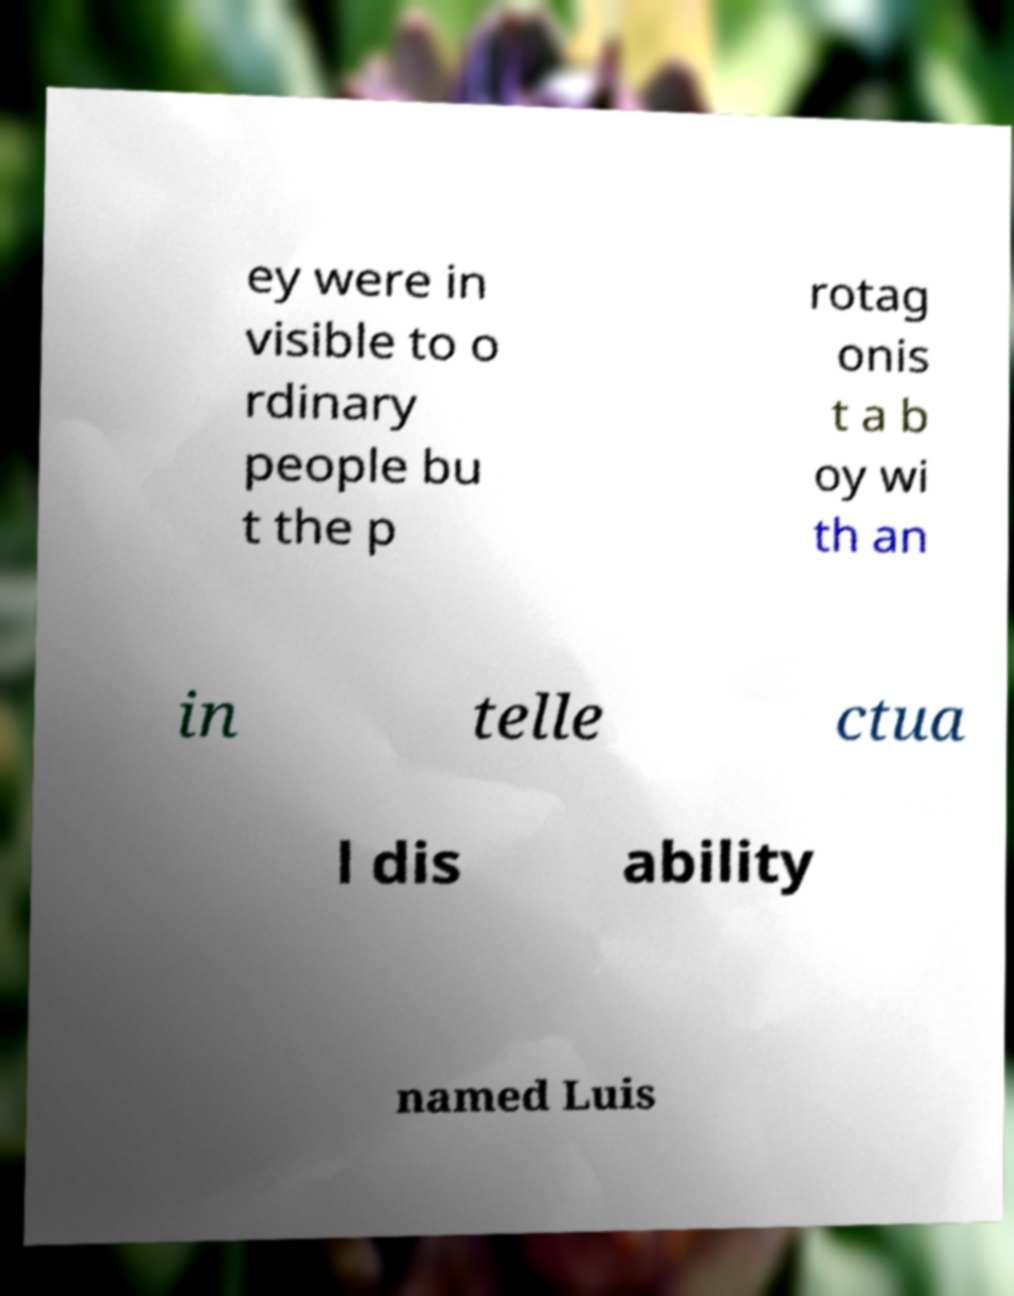Please read and relay the text visible in this image. What does it say? ey were in visible to o rdinary people bu t the p rotag onis t a b oy wi th an in telle ctua l dis ability named Luis 